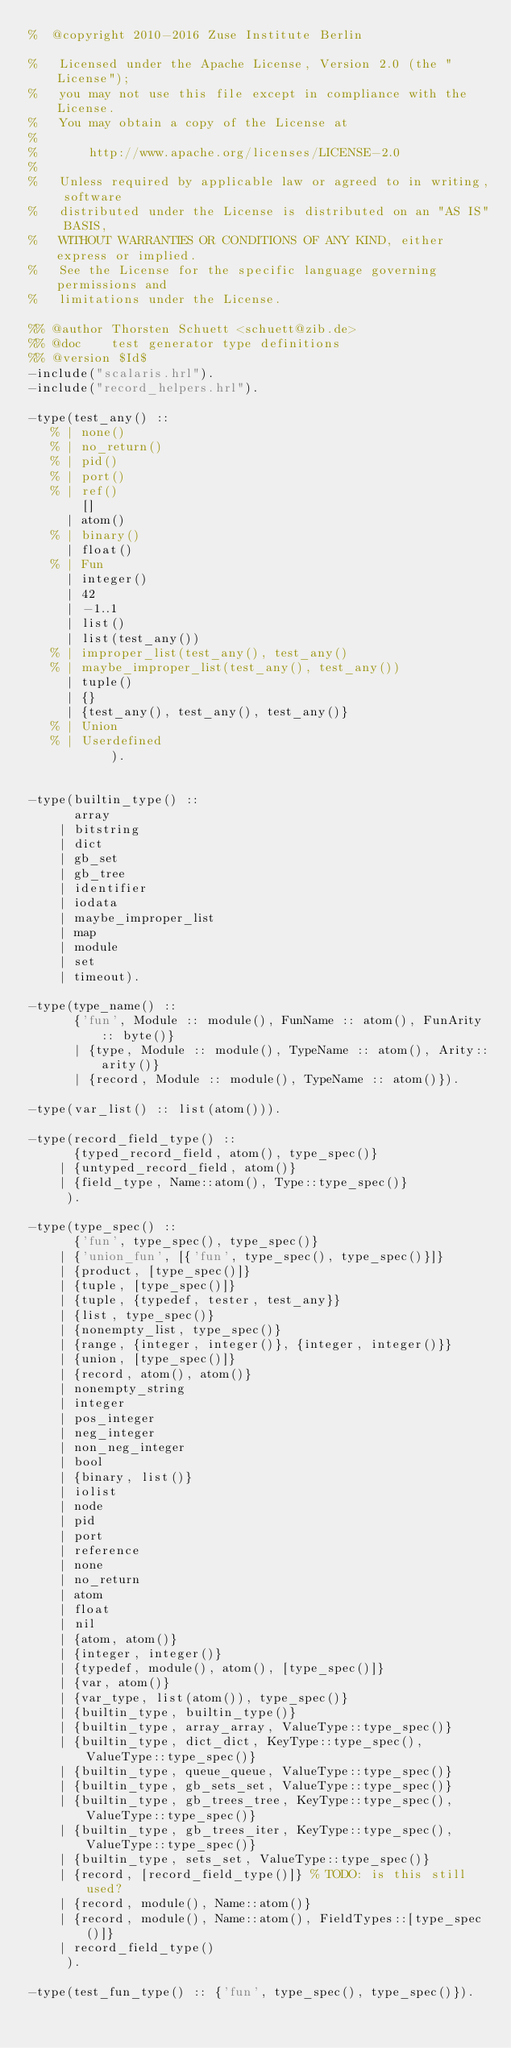Convert code to text. <code><loc_0><loc_0><loc_500><loc_500><_Erlang_>%  @copyright 2010-2016 Zuse Institute Berlin

%   Licensed under the Apache License, Version 2.0 (the "License");
%   you may not use this file except in compliance with the License.
%   You may obtain a copy of the License at
%
%       http://www.apache.org/licenses/LICENSE-2.0
%
%   Unless required by applicable law or agreed to in writing, software
%   distributed under the License is distributed on an "AS IS" BASIS,
%   WITHOUT WARRANTIES OR CONDITIONS OF ANY KIND, either express or implied.
%   See the License for the specific language governing permissions and
%   limitations under the License.

%% @author Thorsten Schuett <schuett@zib.de>
%% @doc    test generator type definitions
%% @version $Id$
-include("scalaris.hrl").
-include("record_helpers.hrl").

-type(test_any() ::
   % | none()
   % | no_return()
   % | pid()
   % | port()
   % | ref()
       []
     | atom()
   % | binary()
     | float()
   % | Fun
     | integer()
     | 42
     | -1..1
     | list()
     | list(test_any())
   % | improper_list(test_any(), test_any()
   % | maybe_improper_list(test_any(), test_any())
     | tuple()
     | {}
     | {test_any(), test_any(), test_any()}
   % | Union
   % | Userdefined
           ).


-type(builtin_type() ::
      array
    | bitstring
    | dict
    | gb_set
    | gb_tree
    | identifier
    | iodata
    | maybe_improper_list
    | map
    | module
    | set
    | timeout).

-type(type_name() ::
      {'fun', Module :: module(), FunName :: atom(), FunArity :: byte()}
      | {type, Module :: module(), TypeName :: atom(), Arity::arity()}
      | {record, Module :: module(), TypeName :: atom()}).

-type(var_list() :: list(atom())).

-type(record_field_type() ::
      {typed_record_field, atom(), type_spec()}
    | {untyped_record_field, atom()}
    | {field_type, Name::atom(), Type::type_spec()}
     ).

-type(type_spec() ::
      {'fun', type_spec(), type_spec()}
    | {'union_fun', [{'fun', type_spec(), type_spec()}]}
    | {product, [type_spec()]}
    | {tuple, [type_spec()]}
    | {tuple, {typedef, tester, test_any}}
    | {list, type_spec()}
    | {nonempty_list, type_spec()}
    | {range, {integer, integer()}, {integer, integer()}}
    | {union, [type_spec()]}
    | {record, atom(), atom()}
    | nonempty_string
    | integer
    | pos_integer
    | neg_integer
    | non_neg_integer
    | bool
    | {binary, list()}
    | iolist
    | node
    | pid
    | port
    | reference
    | none
    | no_return
    | atom
    | float
    | nil
    | {atom, atom()}
    | {integer, integer()}
    | {typedef, module(), atom(), [type_spec()]}
    | {var, atom()}
    | {var_type, list(atom()), type_spec()}
    | {builtin_type, builtin_type()}
    | {builtin_type, array_array, ValueType::type_spec()}
    | {builtin_type, dict_dict, KeyType::type_spec(), ValueType::type_spec()}
    | {builtin_type, queue_queue, ValueType::type_spec()}
    | {builtin_type, gb_sets_set, ValueType::type_spec()}
    | {builtin_type, gb_trees_tree, KeyType::type_spec(), ValueType::type_spec()}
    | {builtin_type, gb_trees_iter, KeyType::type_spec(), ValueType::type_spec()}
    | {builtin_type, sets_set, ValueType::type_spec()}
    | {record, [record_field_type()]} % TODO: is this still used?
    | {record, module(), Name::atom()}
    | {record, module(), Name::atom(), FieldTypes::[type_spec()]}
    | record_field_type()
     ).

-type(test_fun_type() :: {'fun', type_spec(), type_spec()}).
</code> 